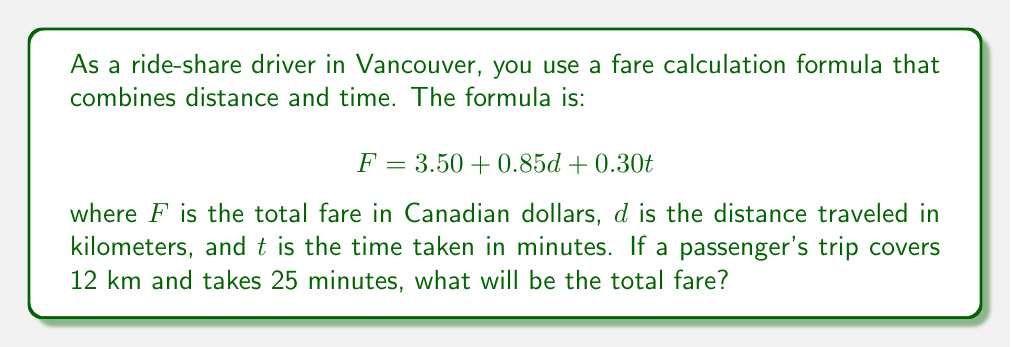Provide a solution to this math problem. To solve this problem, we'll use the given formula and substitute the known values:

$$ F = 3.50 + 0.85d + 0.30t $$

Where:
- $F$ is the total fare (what we're solving for)
- $d = 12$ km (given distance)
- $t = 25$ minutes (given time)

Let's substitute these values into the formula:

$$ F = 3.50 + 0.85(12) + 0.30(25) $$

Now, let's solve step by step:

1. Calculate $0.85d$:
   $0.85 \times 12 = 10.20$

2. Calculate $0.30t$:
   $0.30 \times 25 = 7.50$

3. Sum all parts:
   $$ F = 3.50 + 10.20 + 7.50 $$
   $$ F = 21.20 $$

Therefore, the total fare for this trip will be $21.20 Canadian dollars.
Answer: $21.20 Canadian dollars 